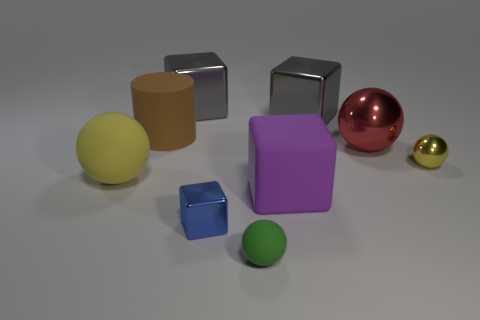Subtract all cyan blocks. How many yellow balls are left? 2 Subtract all green spheres. How many spheres are left? 3 Add 1 big shiny cylinders. How many objects exist? 10 Subtract all blue cubes. How many cubes are left? 3 Subtract 1 balls. How many balls are left? 3 Subtract all cyan cubes. Subtract all purple cylinders. How many cubes are left? 4 Add 7 big purple blocks. How many big purple blocks exist? 8 Subtract 0 brown blocks. How many objects are left? 9 Subtract all blocks. How many objects are left? 5 Subtract all small shiny cubes. Subtract all yellow metal spheres. How many objects are left? 7 